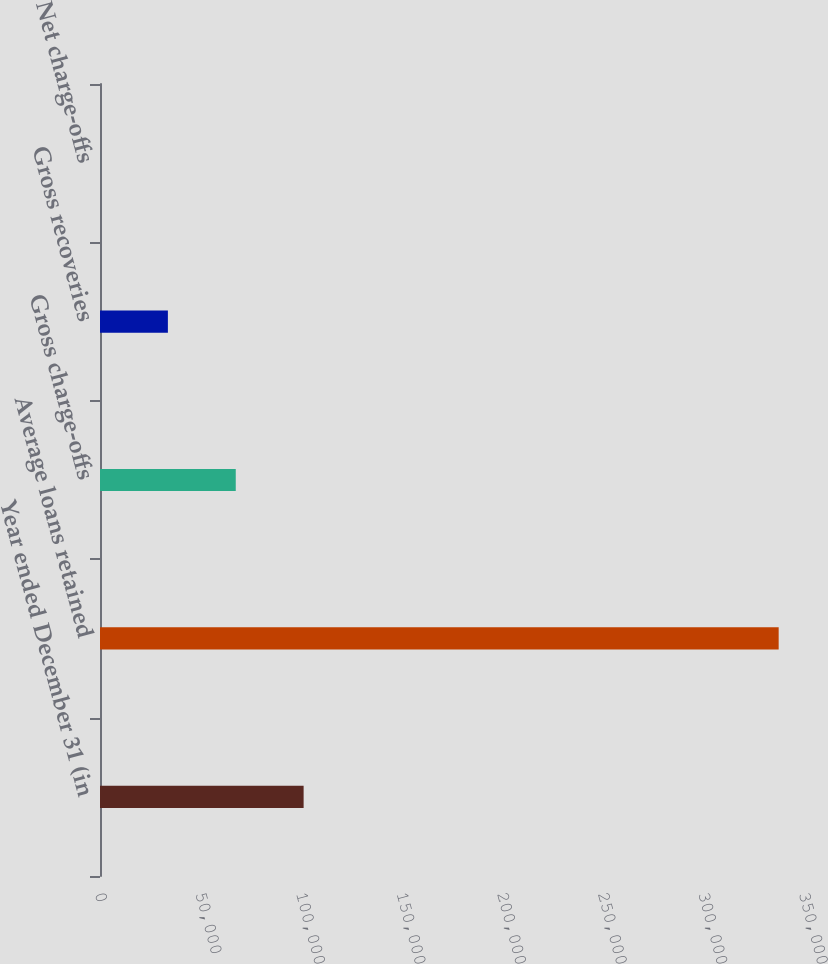Convert chart to OTSL. <chart><loc_0><loc_0><loc_500><loc_500><bar_chart><fcel>Year ended December 31 (in<fcel>Average loans retained<fcel>Gross charge-offs<fcel>Gross recoveries<fcel>Net charge-offs<nl><fcel>101229<fcel>337407<fcel>67489.4<fcel>33749.7<fcel>10<nl></chart> 